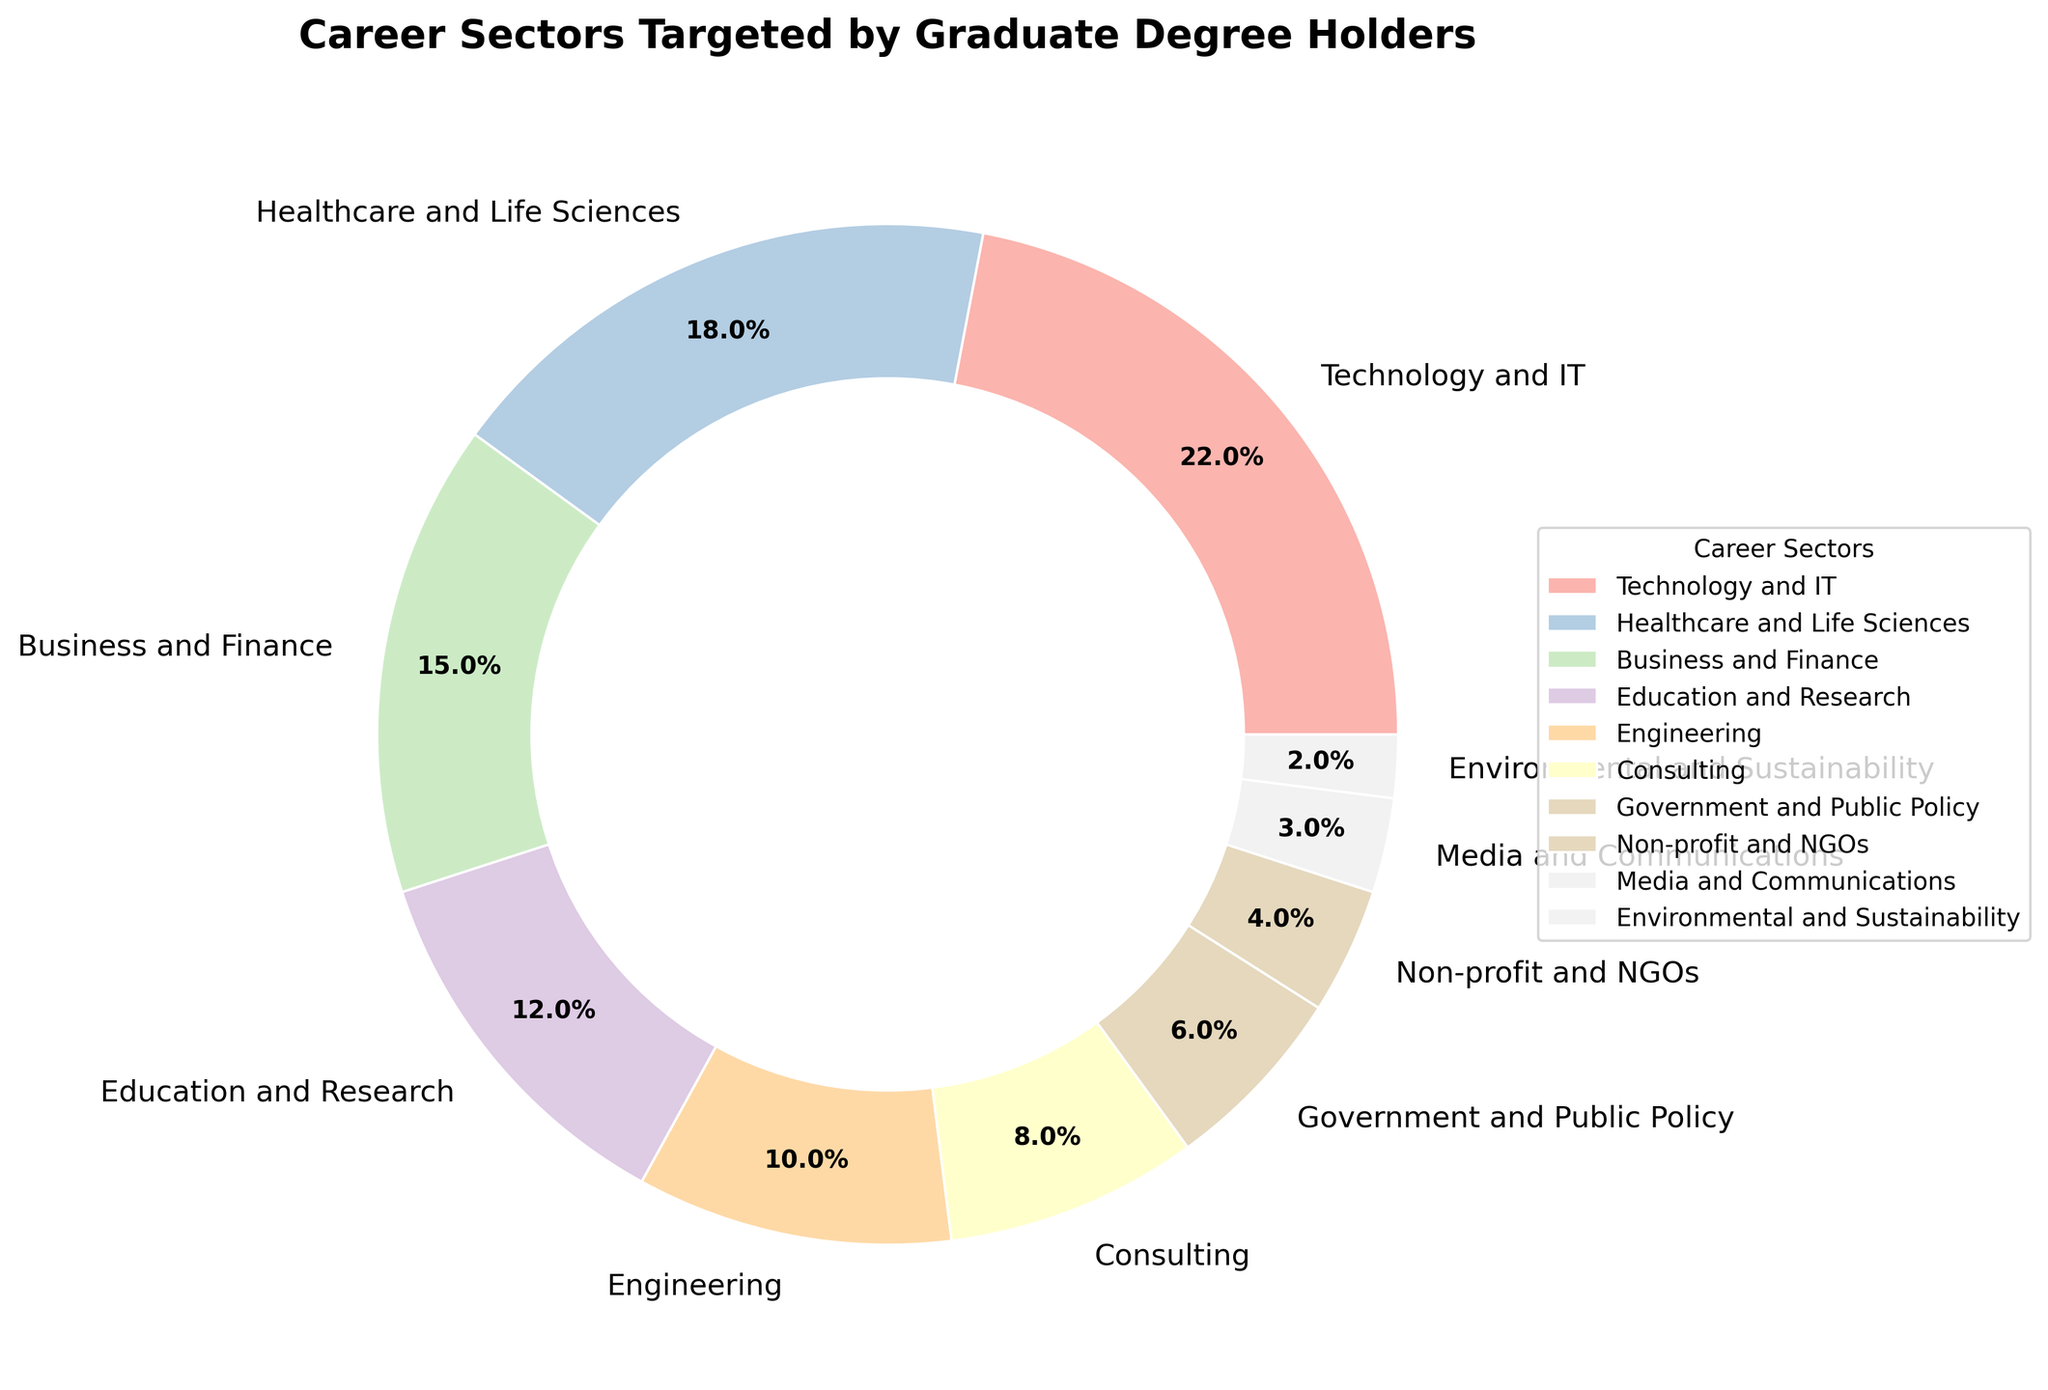What is the percentage of graduate degree holders targeting the Technology and IT sector? Looking at the pie chart, the segment representing Technology and IT shows a percentage. This is directly visible and requires no extra calculation.
Answer: 22% Which sector has a higher percentage, Healthcare and Life Sciences or Education and Research? From the pie chart, compare the values of Healthcare and Life Sciences (18%) with Education and Research (12%). The percentage for Healthcare and Life Sciences is higher.
Answer: Healthcare and Life Sciences What is the combined percentage of graduate degree holders targeting Business and Finance and Consulting? Business and Finance (15%) and Consulting (8%) are summed up. 15% + 8% = 23%
Answer: 23% Which sector has the smallest percentage, and what is it? Look for the smallest segment in the pie chart, which is Environmental and Sustainability. This sector has the smallest percentage.
Answer: Environmental and Sustainability, 2% Is the percentage of graduate degree holders targeting Non-profit and NGOs higher than Media and Communications? Compare the percentages: Non-profit and NGOs (4%) is higher than Media and Communications (3%).
Answer: Yes What is the difference in percentage between those targeting Technology and IT and those targeting Engineering? Technology and IT (22%) minus Engineering (10%) gives the difference. 22% - 10% = 12%
Answer: 12% What sectors combined make up exactly half (50%) of the pie chart? Adding percentages until the total is 50%: Technology and IT (22%) + Healthcare and Life Sciences (18%) + Business and Finance (15%). Their sum is 55%, so that's over. Instead, Technology and IT (22%) + Healthcare and Life Sciences (18%) + Education and Research (12%). Their sum is 52%, so it's still over. Next, Technology and IT (22%) + Healthcare and Life Sciences (18%) + Consulting (8%) = 48%. Adding Environmental and Sustainability (2%) makes it 50%.
Answer: Technology and IT, Healthcare and Life Sciences, Consulting, Environmental and Sustainability Which sector’s segment is visually represented in the darkest shade of color? The pie chart segments use colors ranging from pastel shades. By identifying, the darkest shade is used for the last segment mentioned in the color series, which typically corresponds to Environmental and Sustainability.
Answer: Environmental and Sustainability What is the total percentage of graduate degree holders targeting sectors outside of the top 3 sectors? The top three sectors are Technology and IT (22%), Healthcare and Life Sciences (18%), and Business and Finance (15%). The sum of their percentages is 22% + 18% + 15% = 55%. To find the percentage for other sectors: 100% - 55% = 45%.
Answer: 45% Which sector has a larger percentage, Business and Finance or Government and Public Policy? Compare the percentages from the pie chart: Business and Finance (15%) is larger than Government and Public Policy (6%).
Answer: Business and Finance 